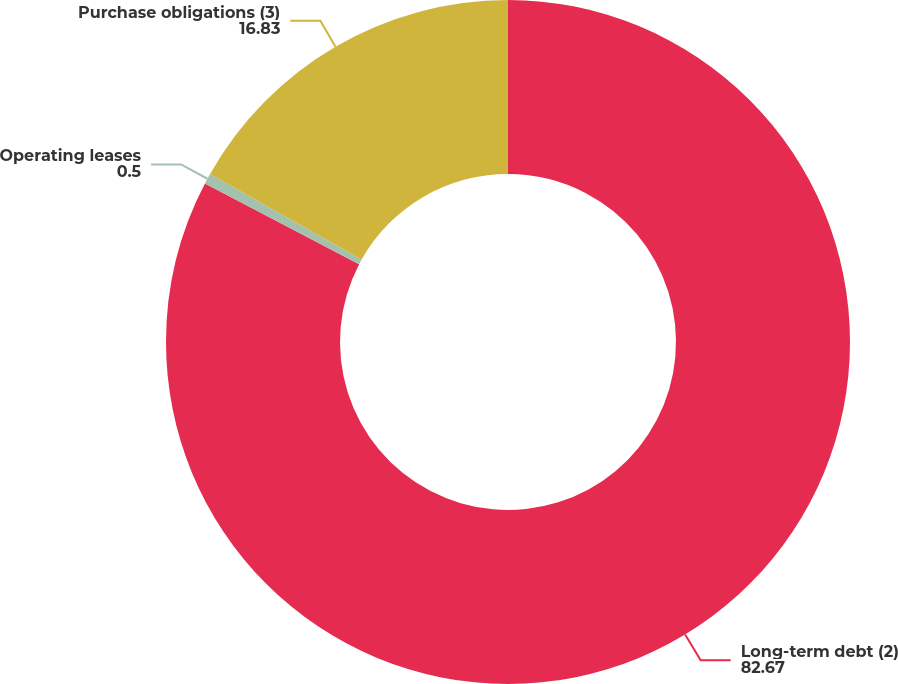Convert chart. <chart><loc_0><loc_0><loc_500><loc_500><pie_chart><fcel>Long-term debt (2)<fcel>Operating leases<fcel>Purchase obligations (3)<nl><fcel>82.67%<fcel>0.5%<fcel>16.83%<nl></chart> 